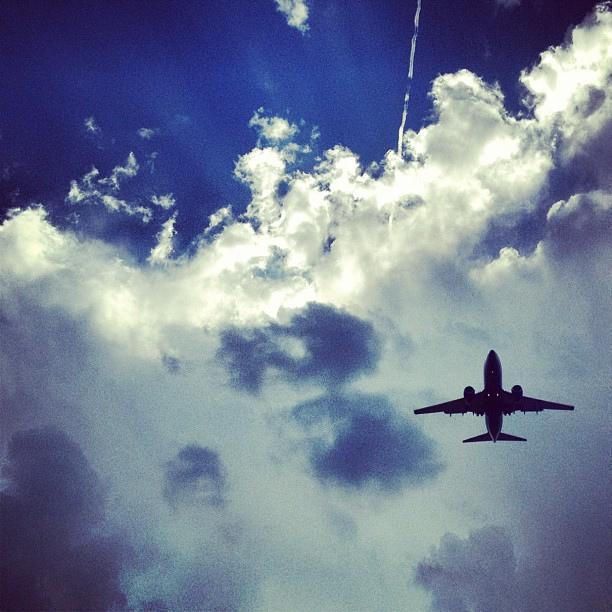How many engines does the plane have?
Give a very brief answer. 2. 